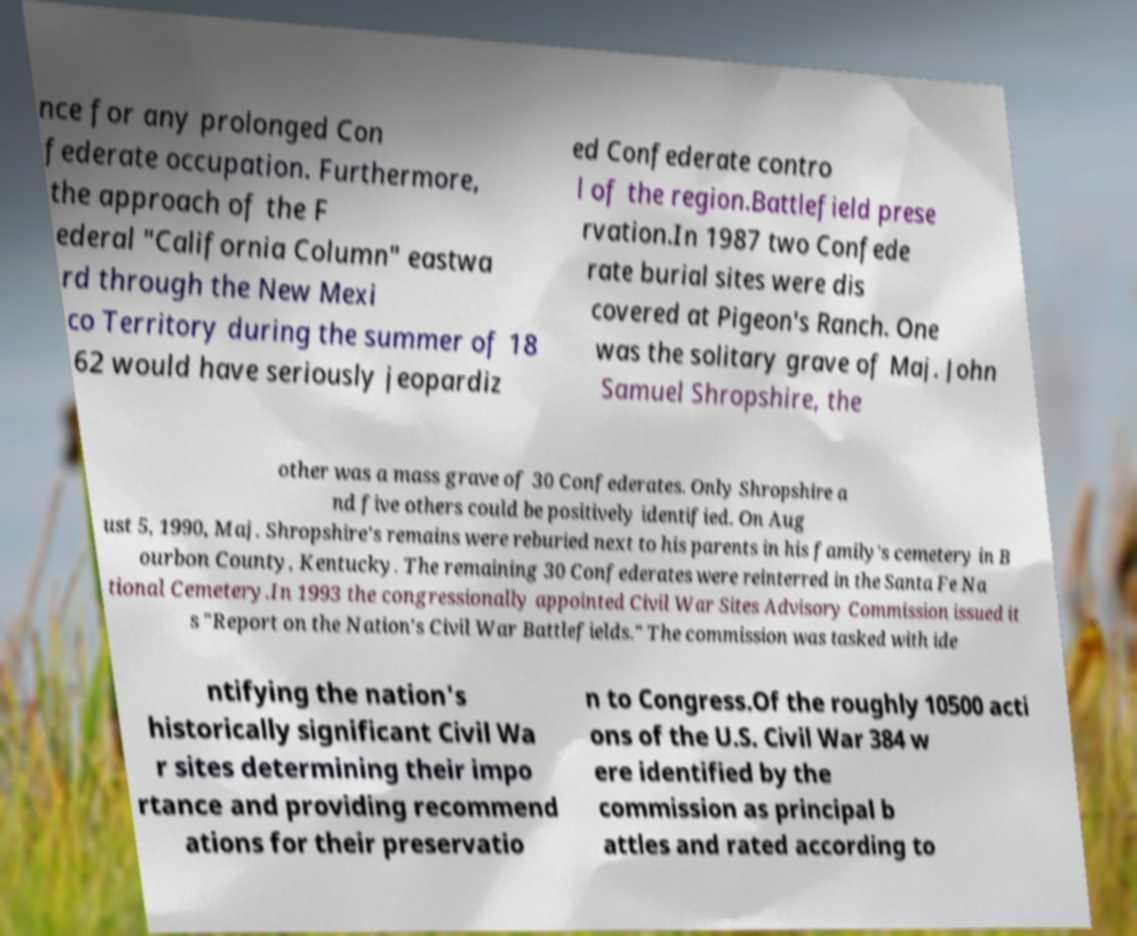I need the written content from this picture converted into text. Can you do that? nce for any prolonged Con federate occupation. Furthermore, the approach of the F ederal "California Column" eastwa rd through the New Mexi co Territory during the summer of 18 62 would have seriously jeopardiz ed Confederate contro l of the region.Battlefield prese rvation.In 1987 two Confede rate burial sites were dis covered at Pigeon's Ranch. One was the solitary grave of Maj. John Samuel Shropshire, the other was a mass grave of 30 Confederates. Only Shropshire a nd five others could be positively identified. On Aug ust 5, 1990, Maj. Shropshire's remains were reburied next to his parents in his family's cemetery in B ourbon County, Kentucky. The remaining 30 Confederates were reinterred in the Santa Fe Na tional Cemetery.In 1993 the congressionally appointed Civil War Sites Advisory Commission issued it s "Report on the Nation's Civil War Battlefields." The commission was tasked with ide ntifying the nation's historically significant Civil Wa r sites determining their impo rtance and providing recommend ations for their preservatio n to Congress.Of the roughly 10500 acti ons of the U.S. Civil War 384 w ere identified by the commission as principal b attles and rated according to 